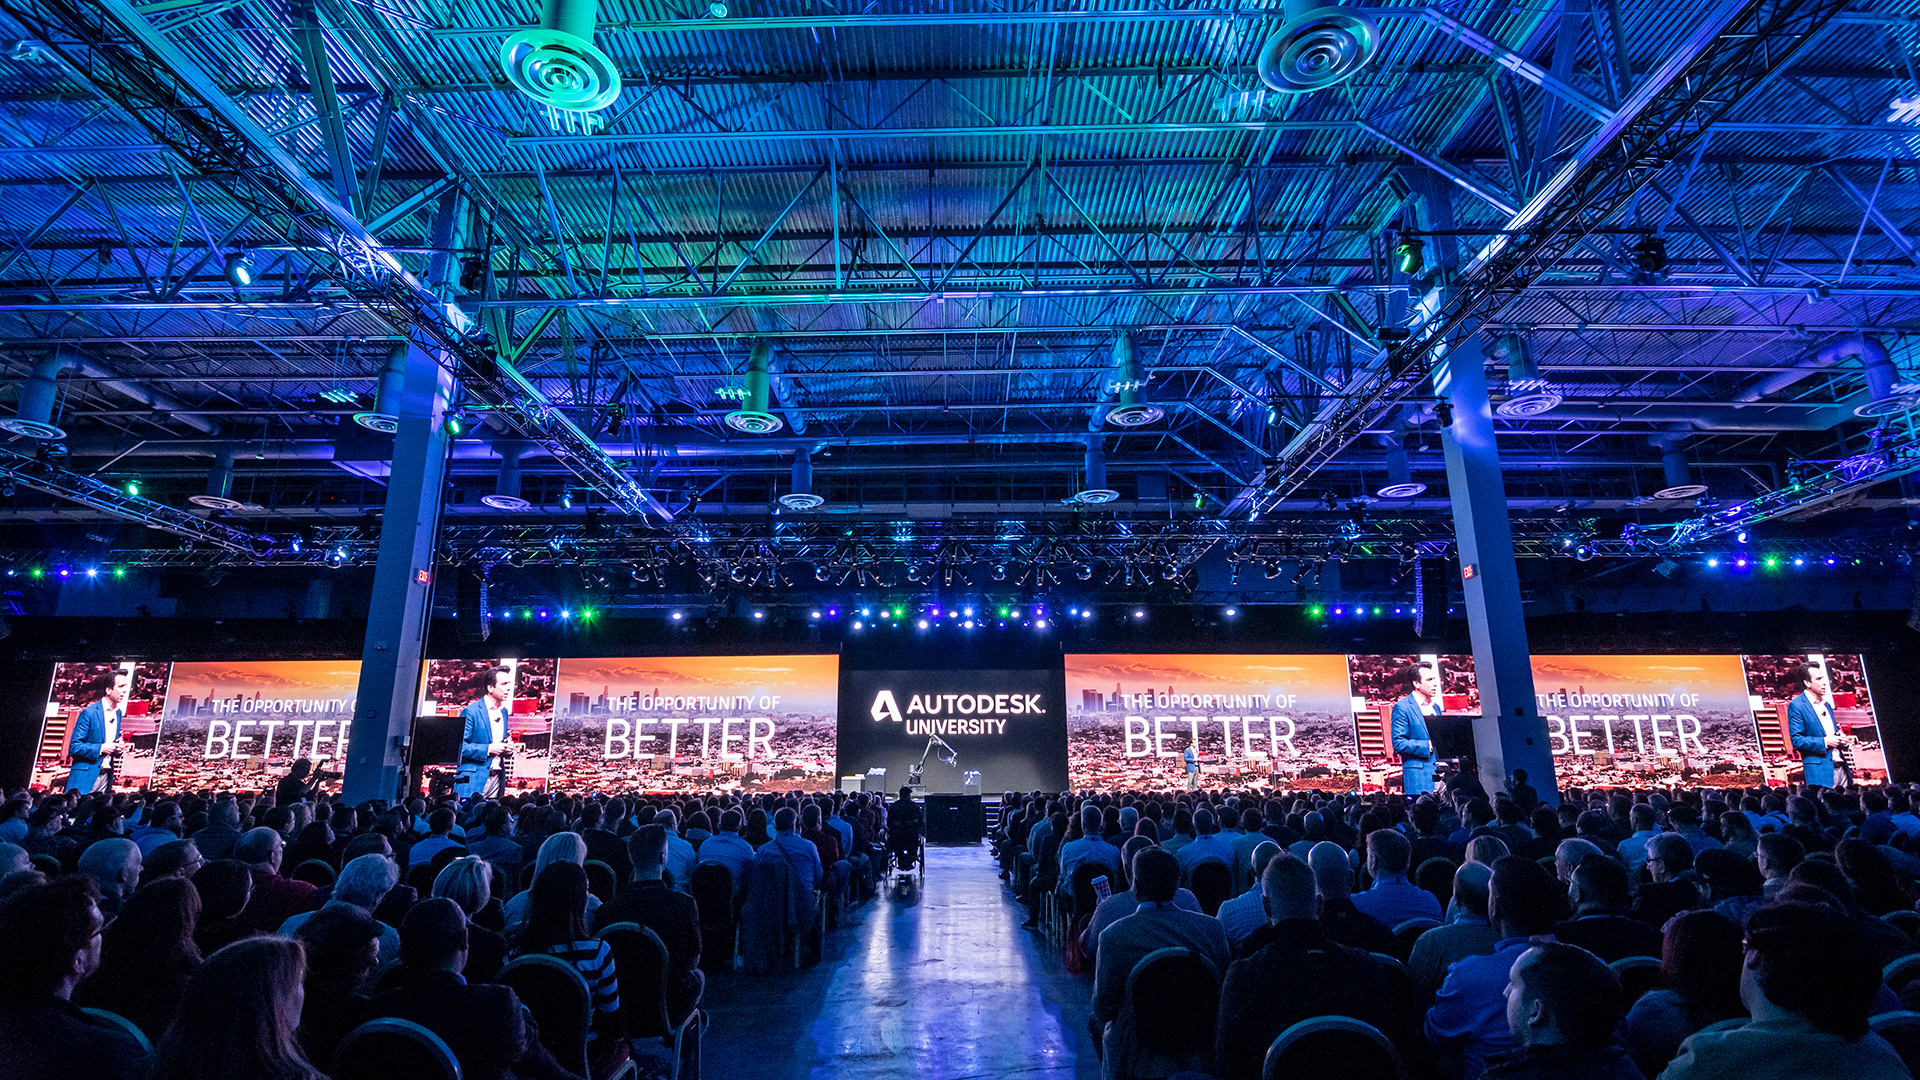What kind of interactive activities might the attendees participate in at this event? Attendees at Autodesk University might engage in a variety of interactive activities such as live software demonstrations, hands-on training sessions with new tools, collaborative workshops on project design, and networking events. Additionally, there could be competitions or challenges related to design and innovation, where participants can showcase their skills. Virtual reality (VR) or augmented reality (AR) experiences demonstrating futuristic design concepts might also be featured, allowing attendees to immerse themselves in cutting-edge technology applications. How might these activities benefit the professionals attending the event? These activities offer numerous benefits to the professionals attending the event. Hands-on training sessions and live demonstrations provide practical skills that can be directly applied in their work, ensuring they stay up-to-date with the latest developments in Autodesk software. Collaborative workshops promote the exchange of ideas and best practices among peers, fostering a sense of community and aiding problem-solving. Networking events create opportunities for professionals to build valuable connections, potentially leading to future collaborations or career advancements. Overall, these immersive experiences not only enhance their technical competencies but also inspire creativity and innovation in their respective fields. 